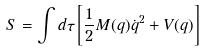Convert formula to latex. <formula><loc_0><loc_0><loc_500><loc_500>S = \int d \tau \left [ \frac { 1 } { 2 } M ( q ) { \dot { q } } ^ { 2 } + V ( q ) \right ]</formula> 